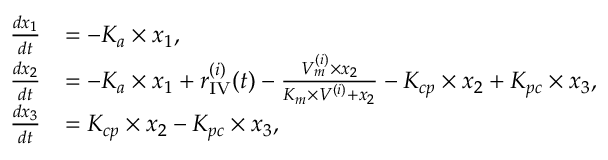Convert formula to latex. <formula><loc_0><loc_0><loc_500><loc_500>\begin{array} { r l } { \frac { d x _ { 1 } } { d t } } & { = - K _ { a } \times x _ { 1 } , } \\ { \frac { d x _ { 2 } } { d t } } & { = - K _ { a } \times x _ { 1 } + r _ { I V } ^ { ( i ) } ( t ) - \frac { V _ { m } ^ { ( i ) } \times x _ { 2 } } { K _ { m } \times V ^ { ( i ) } + x _ { 2 } } - K _ { c p } \times x _ { 2 } + K _ { p c } \times x _ { 3 } , } \\ { \frac { d x _ { 3 } } { d t } } & { = K _ { c p } \times x _ { 2 } - K _ { p c } \times x _ { 3 } , } \end{array}</formula> 